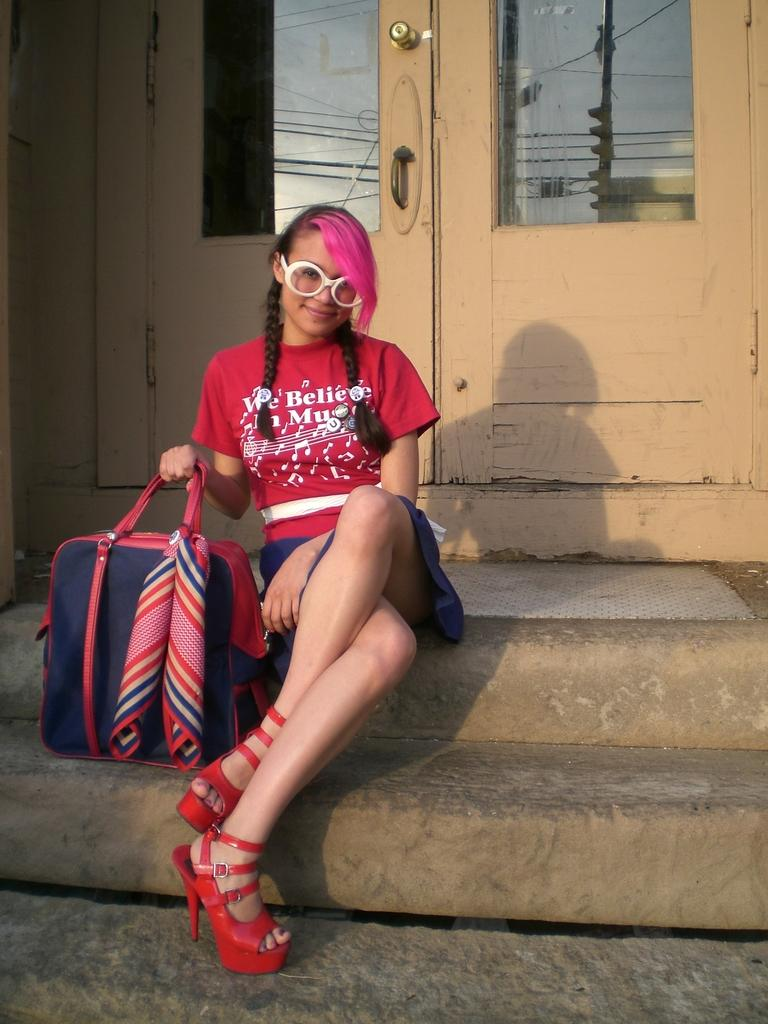What is a prominent feature in the image? There is a door in the image. What is the woman in the image doing? The woman is sitting in the image. What is the woman holding in the image? The woman is holding a bag. What type of rhythm is the woman tapping out with her tongue in the image? There is no indication in the image that the woman is tapping out a rhythm with her tongue, so it cannot be determined from the picture. 